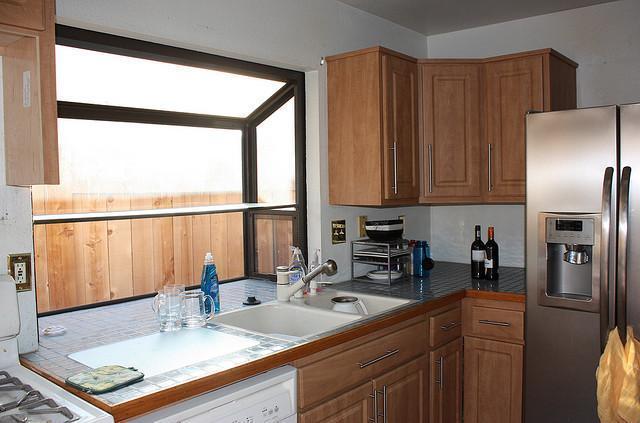How many people are standing on the deck?
Give a very brief answer. 0. 